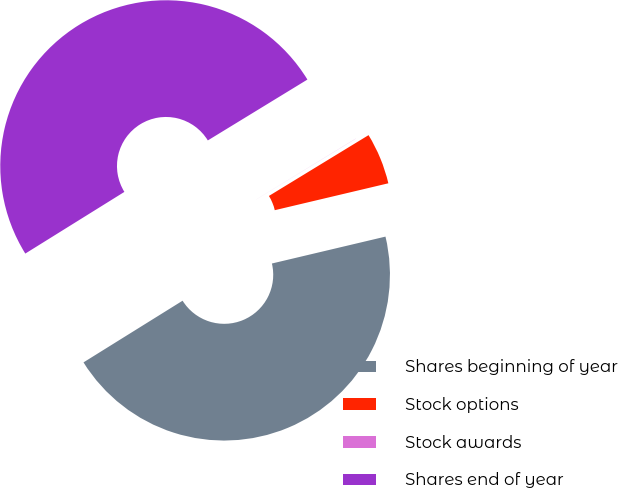Convert chart to OTSL. <chart><loc_0><loc_0><loc_500><loc_500><pie_chart><fcel>Shares beginning of year<fcel>Stock options<fcel>Stock awards<fcel>Shares end of year<nl><fcel>44.84%<fcel>5.02%<fcel>0.01%<fcel>50.13%<nl></chart> 